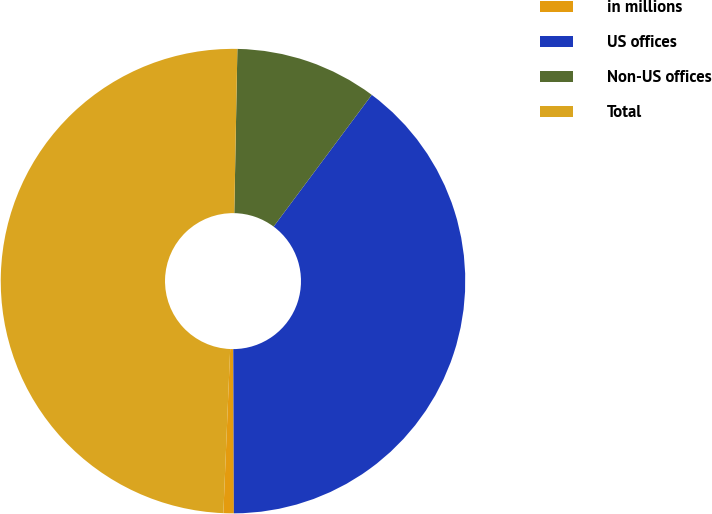Convert chart. <chart><loc_0><loc_0><loc_500><loc_500><pie_chart><fcel>in millions<fcel>US offices<fcel>Non-US offices<fcel>Total<nl><fcel>0.72%<fcel>39.75%<fcel>9.89%<fcel>49.64%<nl></chart> 